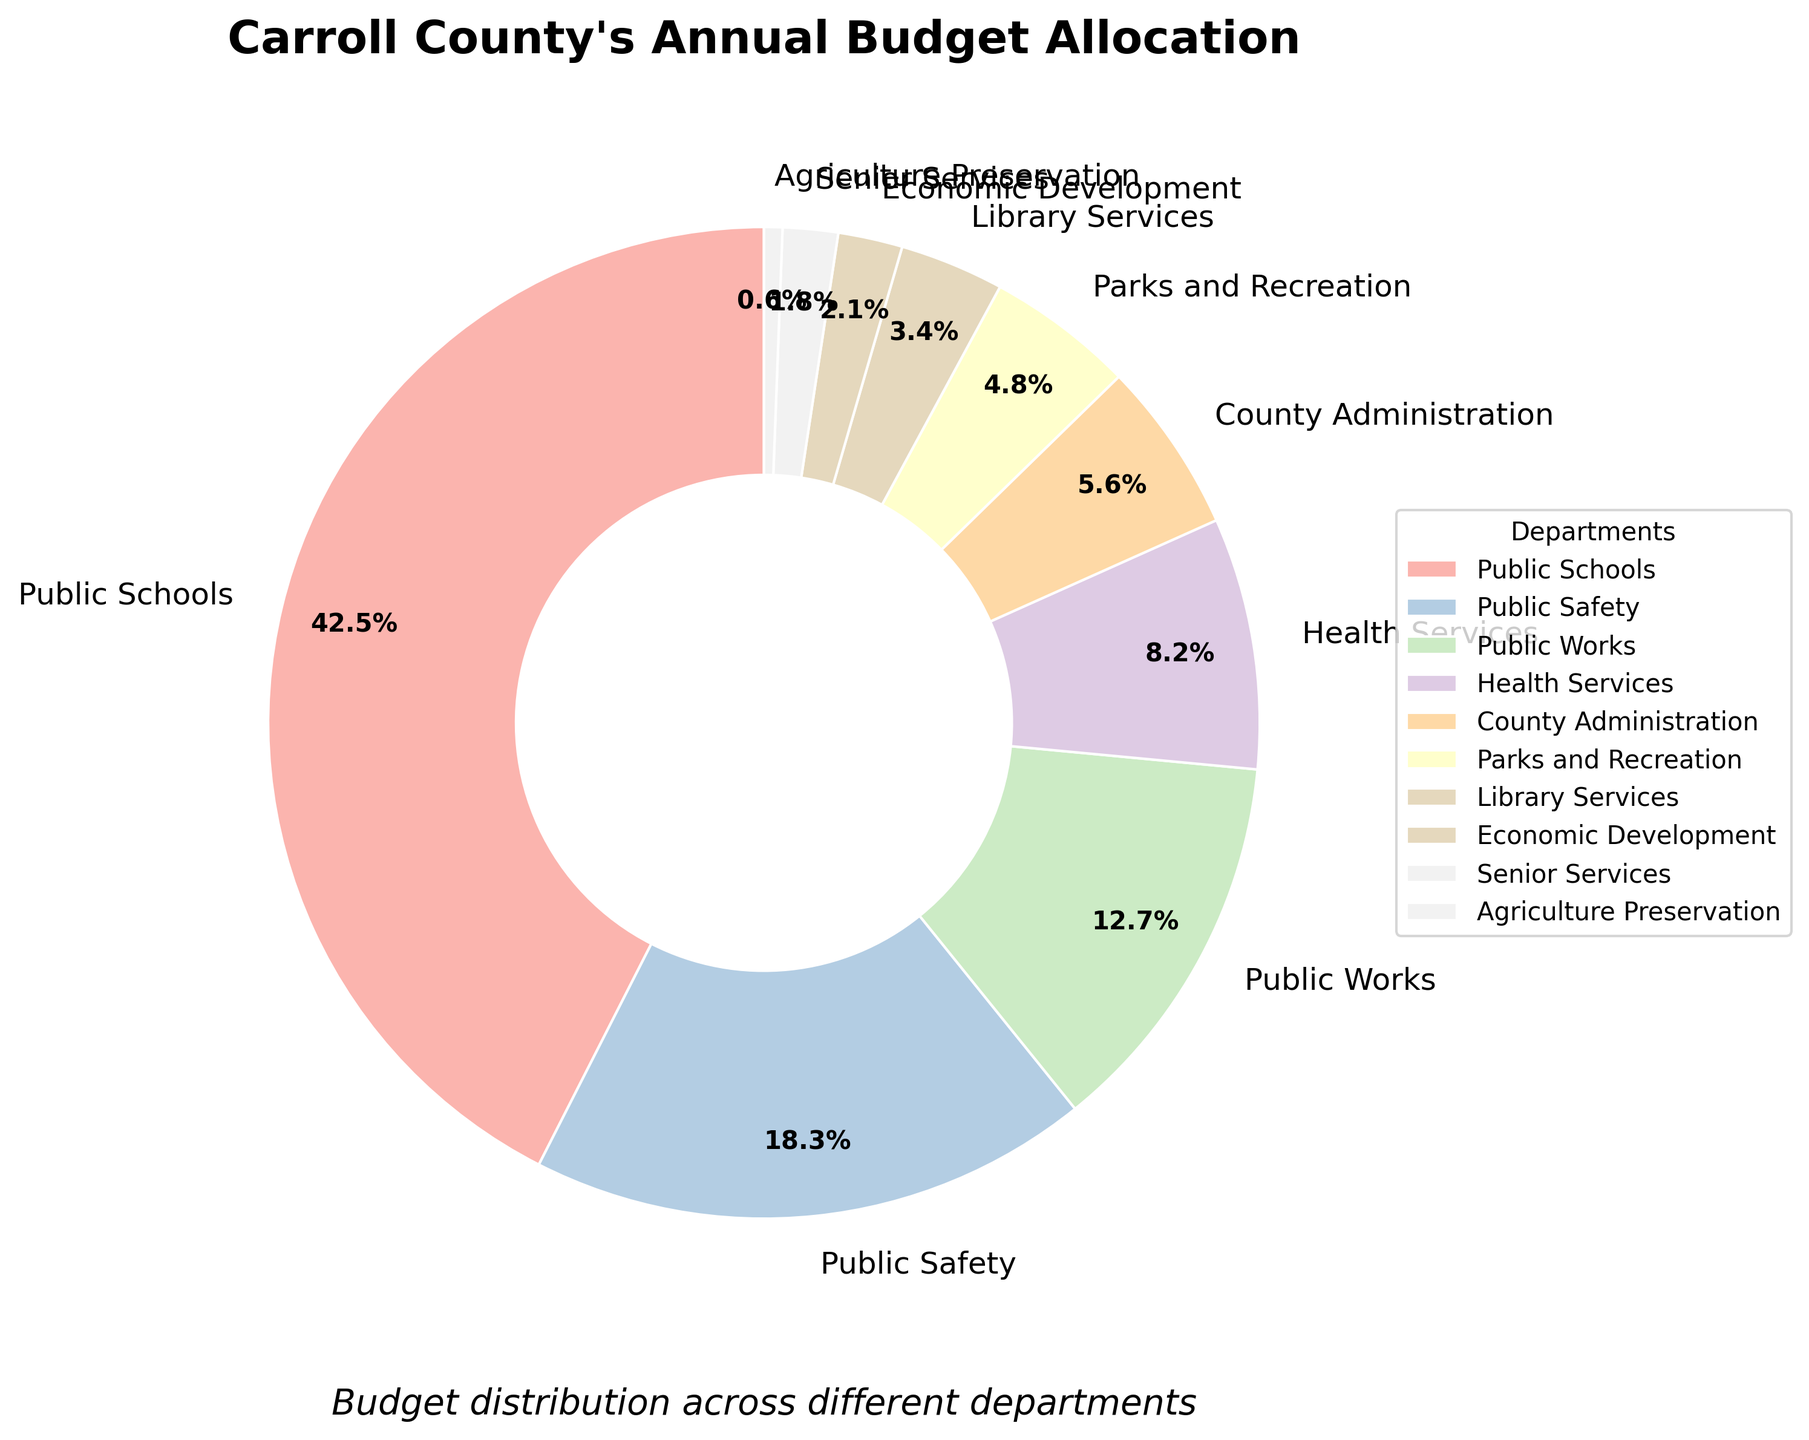What's the department with the highest budget allocation? Look for the largest section of the pie chart, which represents the department with the highest percentage. Public Schools is the largest section with 42.5% of the budget.
Answer: Public Schools Which department has a lower budget allocation, Health Services or Parks and Recreation? Compare the pie sections of Health Services and Parks and Recreation. Health Services is 8.2%, and Parks and Recreation is 4.8%—4.8% (Parks and Recreation) is lower than 8.2%.
Answer: Parks and Recreation What's the total budget allocation for County Administration, Economic Development, and Agriculture Preservation combined? Sum the percentages for the three departments: County Administration (5.6%), Economic Development (2.1%), Agriculture Preservation (0.6%). 5.6 + 2.1 + 0.6 = 8.3%.
Answer: 8.3% Is there a department with less than 1% budget allocation? If so, which one? Look for the section(s) of the pie chart with percentages less than 1%. Agriculture Preservation is the only department under 1% with 0.6%.
Answer: Agriculture Preservation Which is larger, the allocation for Public Works or the combined allocation for Library Services and Senior Services? Calculate the combined percentage for Library Services (3.4%) and Senior Services (1.8%), then compare with Public Works (12.7%). Combined is 3.4 + 1.8 = 5.2%, which is less than 12.7%.
Answer: Public Works What's the ratio of the budget allocation between Public Safety and Senior Services? Divide the percentage of Public Safety (18.3%) by that of Senior Services (1.8%). 18.3 / 1.8 = 10.17.
Answer: 10.17 How many departments have budget allocations greater than 10%? Identify sections of the pie chart with percentages greater than 10%. Public Schools (42.5%), Public Safety (18.3%), and Public Works (12.7%) are the departments. There are three departments in total.
Answer: 3 departments If the total budget is $100 million, how much is allocated to Parks and Recreation? Calculate the amount by multiplying the percentage for Parks and Recreation (4.8%) by the total budget ($100 million). 4.8% of $100 million is 4.8 / 100 * 100,000,000 = $4.8 million.
Answer: $4.8 million 